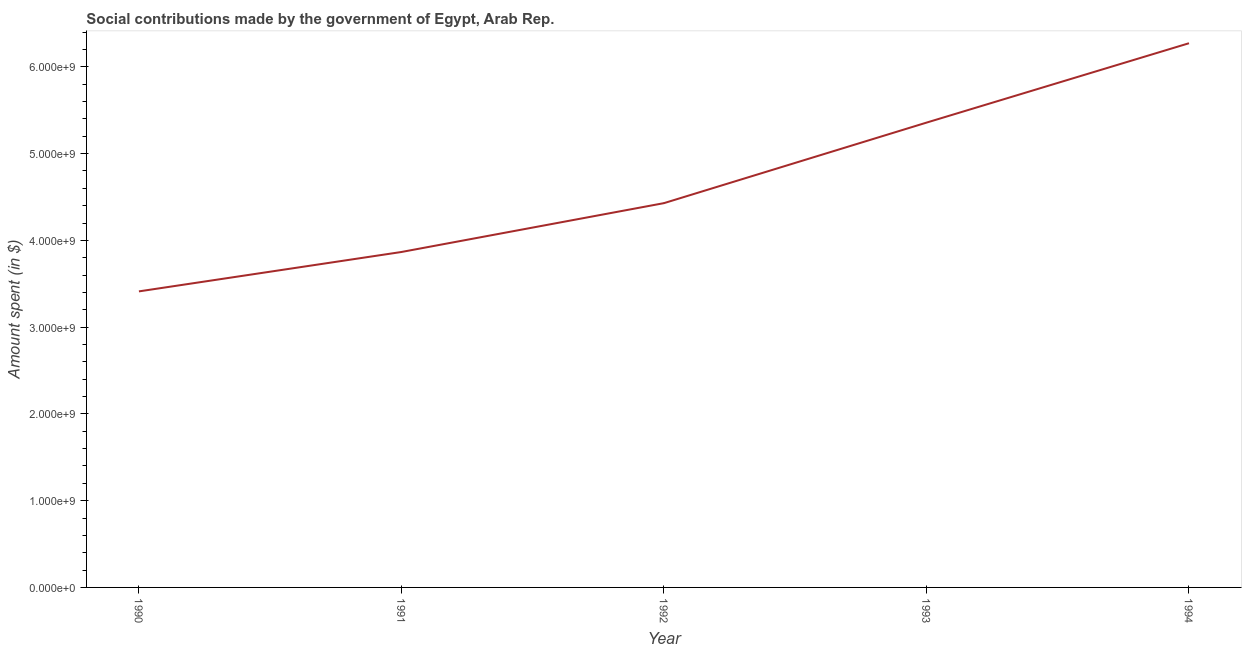What is the amount spent in making social contributions in 1991?
Your answer should be very brief. 3.87e+09. Across all years, what is the maximum amount spent in making social contributions?
Offer a terse response. 6.27e+09. Across all years, what is the minimum amount spent in making social contributions?
Your answer should be very brief. 3.41e+09. In which year was the amount spent in making social contributions maximum?
Provide a succinct answer. 1994. In which year was the amount spent in making social contributions minimum?
Provide a short and direct response. 1990. What is the sum of the amount spent in making social contributions?
Keep it short and to the point. 2.33e+1. What is the difference between the amount spent in making social contributions in 1990 and 1991?
Your response must be concise. -4.54e+08. What is the average amount spent in making social contributions per year?
Keep it short and to the point. 4.67e+09. What is the median amount spent in making social contributions?
Give a very brief answer. 4.43e+09. Do a majority of the years between 1990 and 1991 (inclusive) have amount spent in making social contributions greater than 3800000000 $?
Provide a succinct answer. No. What is the ratio of the amount spent in making social contributions in 1990 to that in 1991?
Provide a succinct answer. 0.88. Is the difference between the amount spent in making social contributions in 1991 and 1994 greater than the difference between any two years?
Make the answer very short. No. What is the difference between the highest and the second highest amount spent in making social contributions?
Make the answer very short. 9.15e+08. Is the sum of the amount spent in making social contributions in 1992 and 1993 greater than the maximum amount spent in making social contributions across all years?
Make the answer very short. Yes. What is the difference between the highest and the lowest amount spent in making social contributions?
Ensure brevity in your answer.  2.86e+09. In how many years, is the amount spent in making social contributions greater than the average amount spent in making social contributions taken over all years?
Your answer should be compact. 2. Does the amount spent in making social contributions monotonically increase over the years?
Offer a terse response. Yes. How many years are there in the graph?
Your answer should be compact. 5. Are the values on the major ticks of Y-axis written in scientific E-notation?
Offer a very short reply. Yes. Does the graph contain any zero values?
Keep it short and to the point. No. What is the title of the graph?
Offer a very short reply. Social contributions made by the government of Egypt, Arab Rep. What is the label or title of the X-axis?
Your response must be concise. Year. What is the label or title of the Y-axis?
Provide a succinct answer. Amount spent (in $). What is the Amount spent (in $) in 1990?
Your answer should be compact. 3.41e+09. What is the Amount spent (in $) in 1991?
Your response must be concise. 3.87e+09. What is the Amount spent (in $) of 1992?
Keep it short and to the point. 4.43e+09. What is the Amount spent (in $) in 1993?
Provide a succinct answer. 5.36e+09. What is the Amount spent (in $) of 1994?
Provide a succinct answer. 6.27e+09. What is the difference between the Amount spent (in $) in 1990 and 1991?
Your answer should be very brief. -4.54e+08. What is the difference between the Amount spent (in $) in 1990 and 1992?
Provide a short and direct response. -1.02e+09. What is the difference between the Amount spent (in $) in 1990 and 1993?
Your response must be concise. -1.94e+09. What is the difference between the Amount spent (in $) in 1990 and 1994?
Provide a succinct answer. -2.86e+09. What is the difference between the Amount spent (in $) in 1991 and 1992?
Give a very brief answer. -5.63e+08. What is the difference between the Amount spent (in $) in 1991 and 1993?
Offer a terse response. -1.49e+09. What is the difference between the Amount spent (in $) in 1991 and 1994?
Give a very brief answer. -2.41e+09. What is the difference between the Amount spent (in $) in 1992 and 1993?
Your answer should be compact. -9.28e+08. What is the difference between the Amount spent (in $) in 1992 and 1994?
Offer a terse response. -1.84e+09. What is the difference between the Amount spent (in $) in 1993 and 1994?
Ensure brevity in your answer.  -9.15e+08. What is the ratio of the Amount spent (in $) in 1990 to that in 1991?
Keep it short and to the point. 0.88. What is the ratio of the Amount spent (in $) in 1990 to that in 1992?
Your answer should be compact. 0.77. What is the ratio of the Amount spent (in $) in 1990 to that in 1993?
Give a very brief answer. 0.64. What is the ratio of the Amount spent (in $) in 1990 to that in 1994?
Make the answer very short. 0.54. What is the ratio of the Amount spent (in $) in 1991 to that in 1992?
Ensure brevity in your answer.  0.87. What is the ratio of the Amount spent (in $) in 1991 to that in 1993?
Make the answer very short. 0.72. What is the ratio of the Amount spent (in $) in 1991 to that in 1994?
Your answer should be very brief. 0.62. What is the ratio of the Amount spent (in $) in 1992 to that in 1993?
Ensure brevity in your answer.  0.83. What is the ratio of the Amount spent (in $) in 1992 to that in 1994?
Ensure brevity in your answer.  0.71. What is the ratio of the Amount spent (in $) in 1993 to that in 1994?
Ensure brevity in your answer.  0.85. 